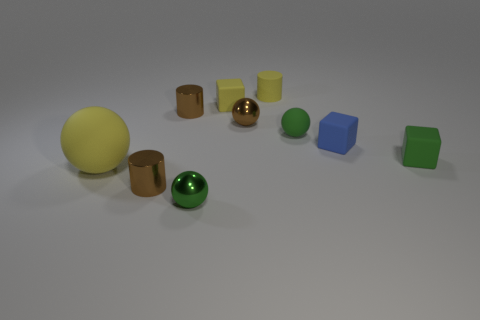Do the big yellow ball and the small blue block have the same material?
Offer a very short reply. Yes. There is a tiny brown thing that is the same shape as the big yellow object; what material is it?
Make the answer very short. Metal. Is the number of yellow matte spheres on the right side of the yellow matte cylinder less than the number of green shiny things?
Provide a short and direct response. Yes. How many small blue things are behind the tiny matte sphere?
Offer a very short reply. 0. There is a tiny green matte object that is behind the tiny blue object; does it have the same shape as the tiny green metal thing in front of the big yellow rubber object?
Keep it short and to the point. Yes. What shape is the brown object that is to the left of the brown metallic sphere and behind the tiny blue matte block?
Ensure brevity in your answer.  Cylinder. There is a yellow sphere that is the same material as the small blue object; what is its size?
Your answer should be very brief. Large. Are there fewer yellow rubber blocks than tiny matte things?
Make the answer very short. Yes. There is a cube that is to the left of the yellow cylinder to the right of the tiny yellow thing that is to the left of the tiny yellow rubber cylinder; what is it made of?
Make the answer very short. Rubber. Does the yellow object in front of the blue matte thing have the same material as the tiny yellow thing that is to the right of the brown ball?
Your answer should be very brief. Yes. 